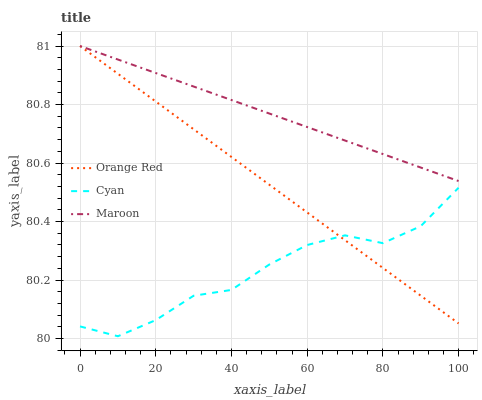Does Cyan have the minimum area under the curve?
Answer yes or no. Yes. Does Maroon have the maximum area under the curve?
Answer yes or no. Yes. Does Orange Red have the minimum area under the curve?
Answer yes or no. No. Does Orange Red have the maximum area under the curve?
Answer yes or no. No. Is Orange Red the smoothest?
Answer yes or no. Yes. Is Cyan the roughest?
Answer yes or no. Yes. Is Maroon the smoothest?
Answer yes or no. No. Is Maroon the roughest?
Answer yes or no. No. Does Cyan have the lowest value?
Answer yes or no. Yes. Does Orange Red have the lowest value?
Answer yes or no. No. Does Maroon have the highest value?
Answer yes or no. Yes. Is Cyan less than Maroon?
Answer yes or no. Yes. Is Maroon greater than Cyan?
Answer yes or no. Yes. Does Orange Red intersect Maroon?
Answer yes or no. Yes. Is Orange Red less than Maroon?
Answer yes or no. No. Is Orange Red greater than Maroon?
Answer yes or no. No. Does Cyan intersect Maroon?
Answer yes or no. No. 